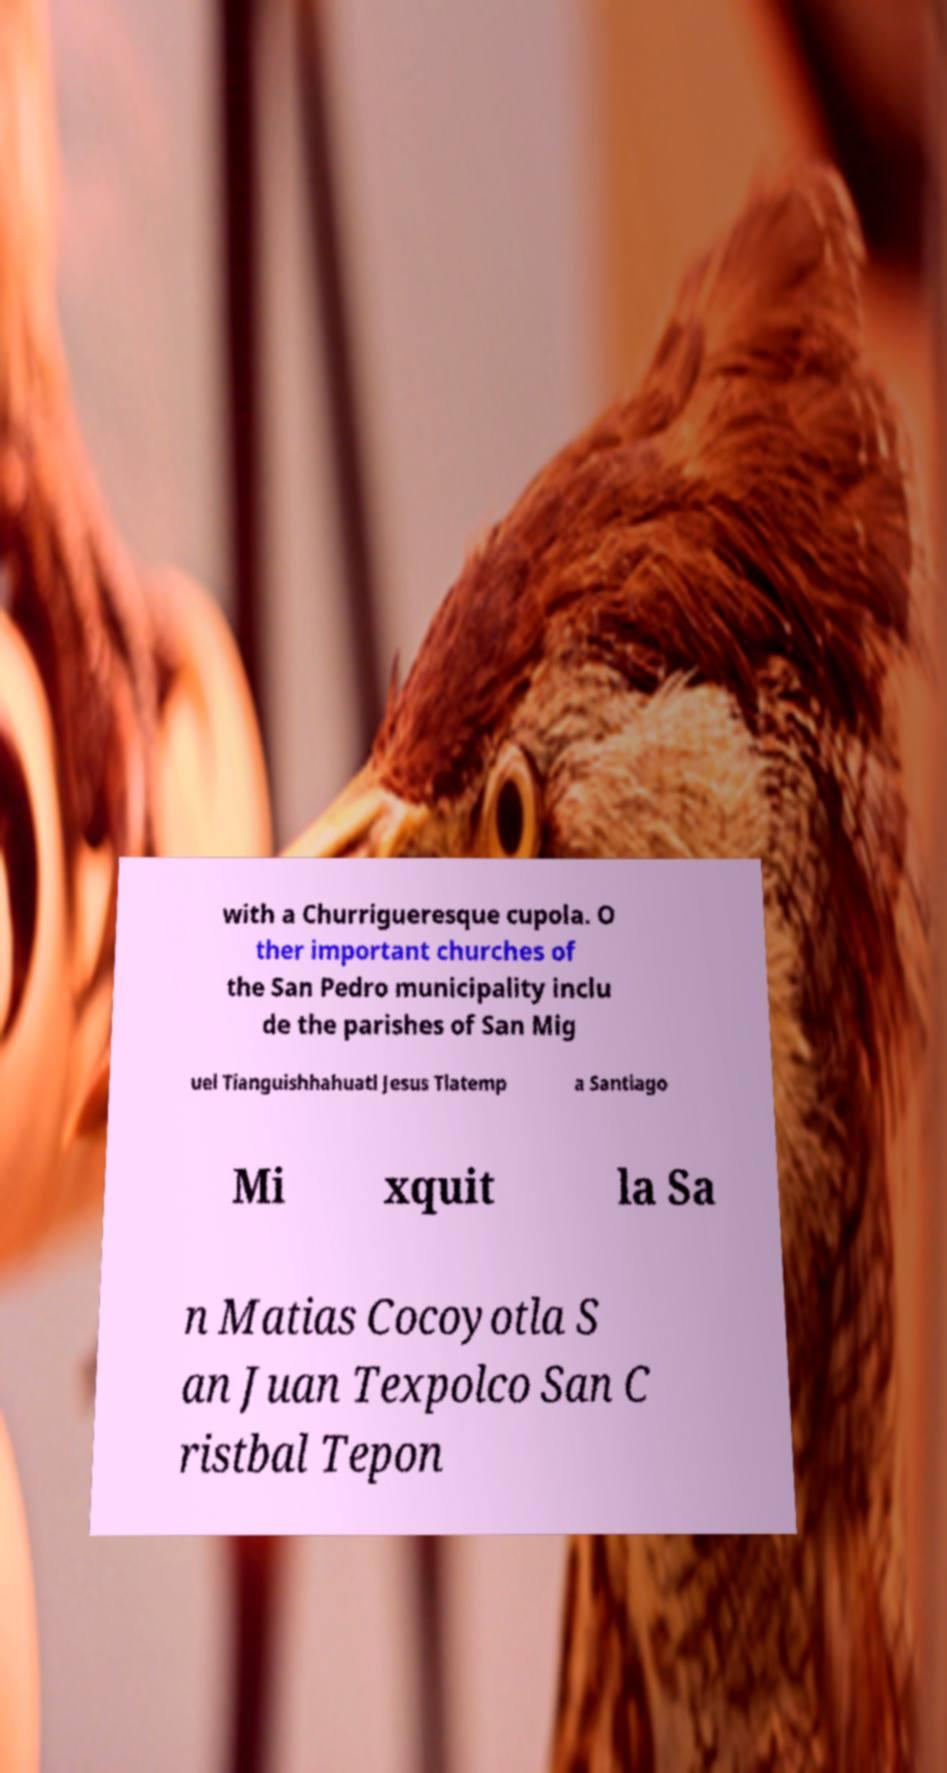I need the written content from this picture converted into text. Can you do that? with a Churrigueresque cupola. O ther important churches of the San Pedro municipality inclu de the parishes of San Mig uel Tianguishhahuatl Jesus Tlatemp a Santiago Mi xquit la Sa n Matias Cocoyotla S an Juan Texpolco San C ristbal Tepon 